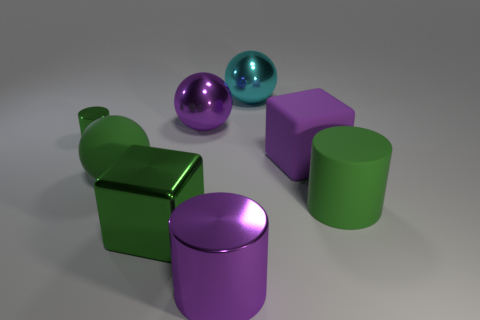Subtract all big metal spheres. How many spheres are left? 1 Subtract 1 balls. How many balls are left? 2 Subtract all cylinders. How many objects are left? 5 Subtract all cyan blocks. How many green cylinders are left? 2 Add 1 large matte blocks. How many objects exist? 9 Subtract all large gray rubber cylinders. Subtract all tiny green things. How many objects are left? 7 Add 6 purple cubes. How many purple cubes are left? 7 Add 1 green shiny things. How many green shiny things exist? 3 Subtract all purple blocks. How many blocks are left? 1 Subtract 1 purple cubes. How many objects are left? 7 